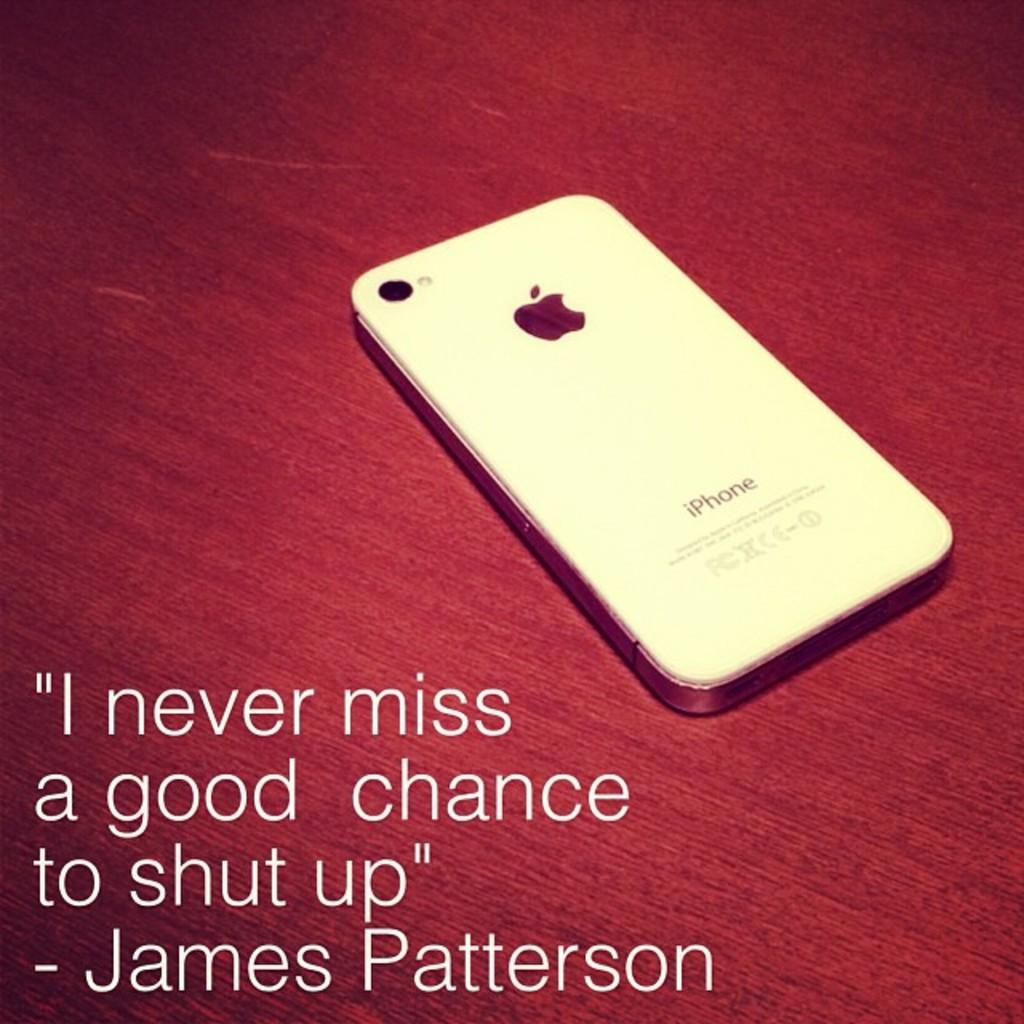Provide a one-sentence caption for the provided image. A white phone, imprinted iPhone, with an apple on it is laying face down on a red surface. 